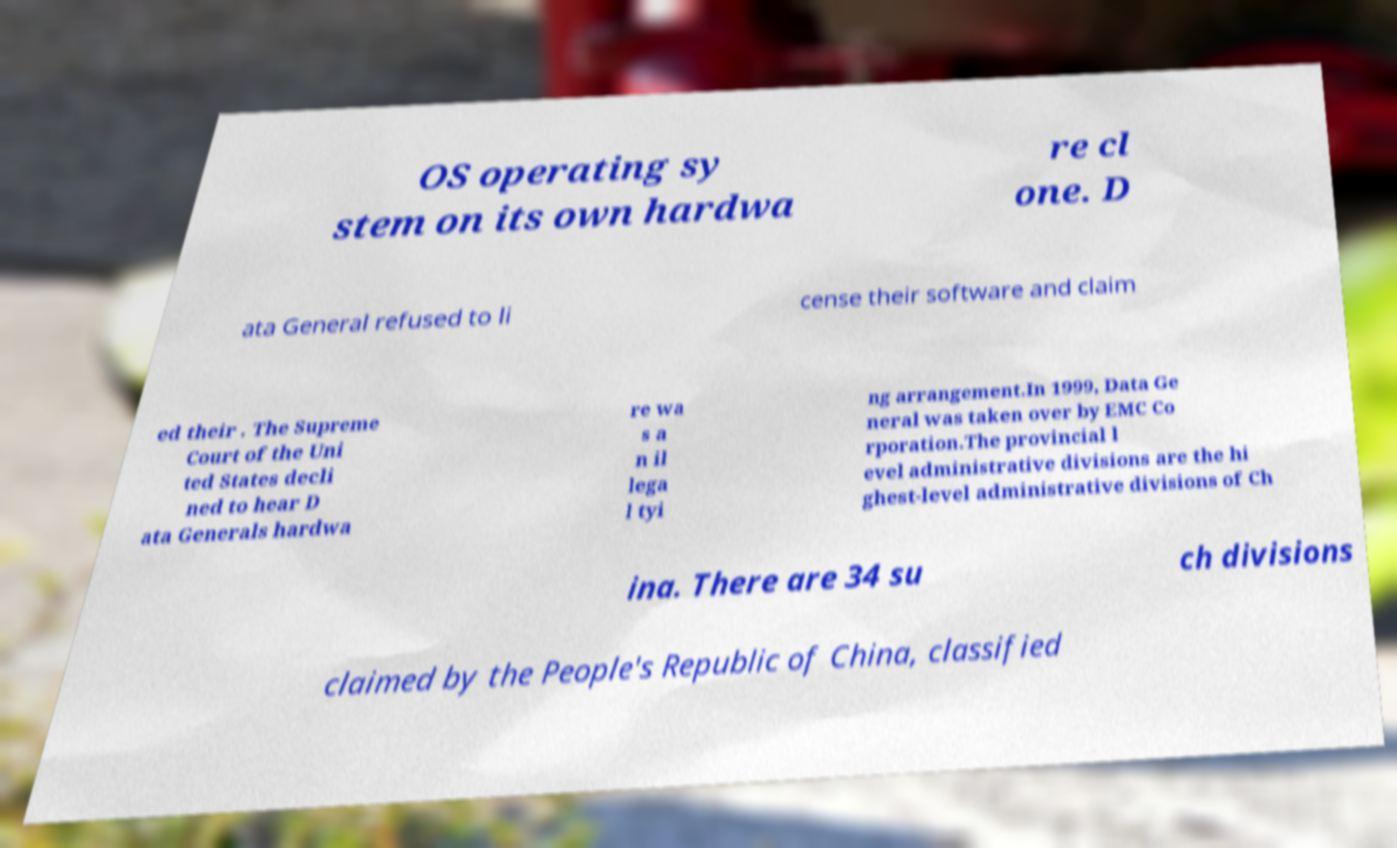Can you accurately transcribe the text from the provided image for me? OS operating sy stem on its own hardwa re cl one. D ata General refused to li cense their software and claim ed their . The Supreme Court of the Uni ted States decli ned to hear D ata Generals hardwa re wa s a n il lega l tyi ng arrangement.In 1999, Data Ge neral was taken over by EMC Co rporation.The provincial l evel administrative divisions are the hi ghest-level administrative divisions of Ch ina. There are 34 su ch divisions claimed by the People's Republic of China, classified 